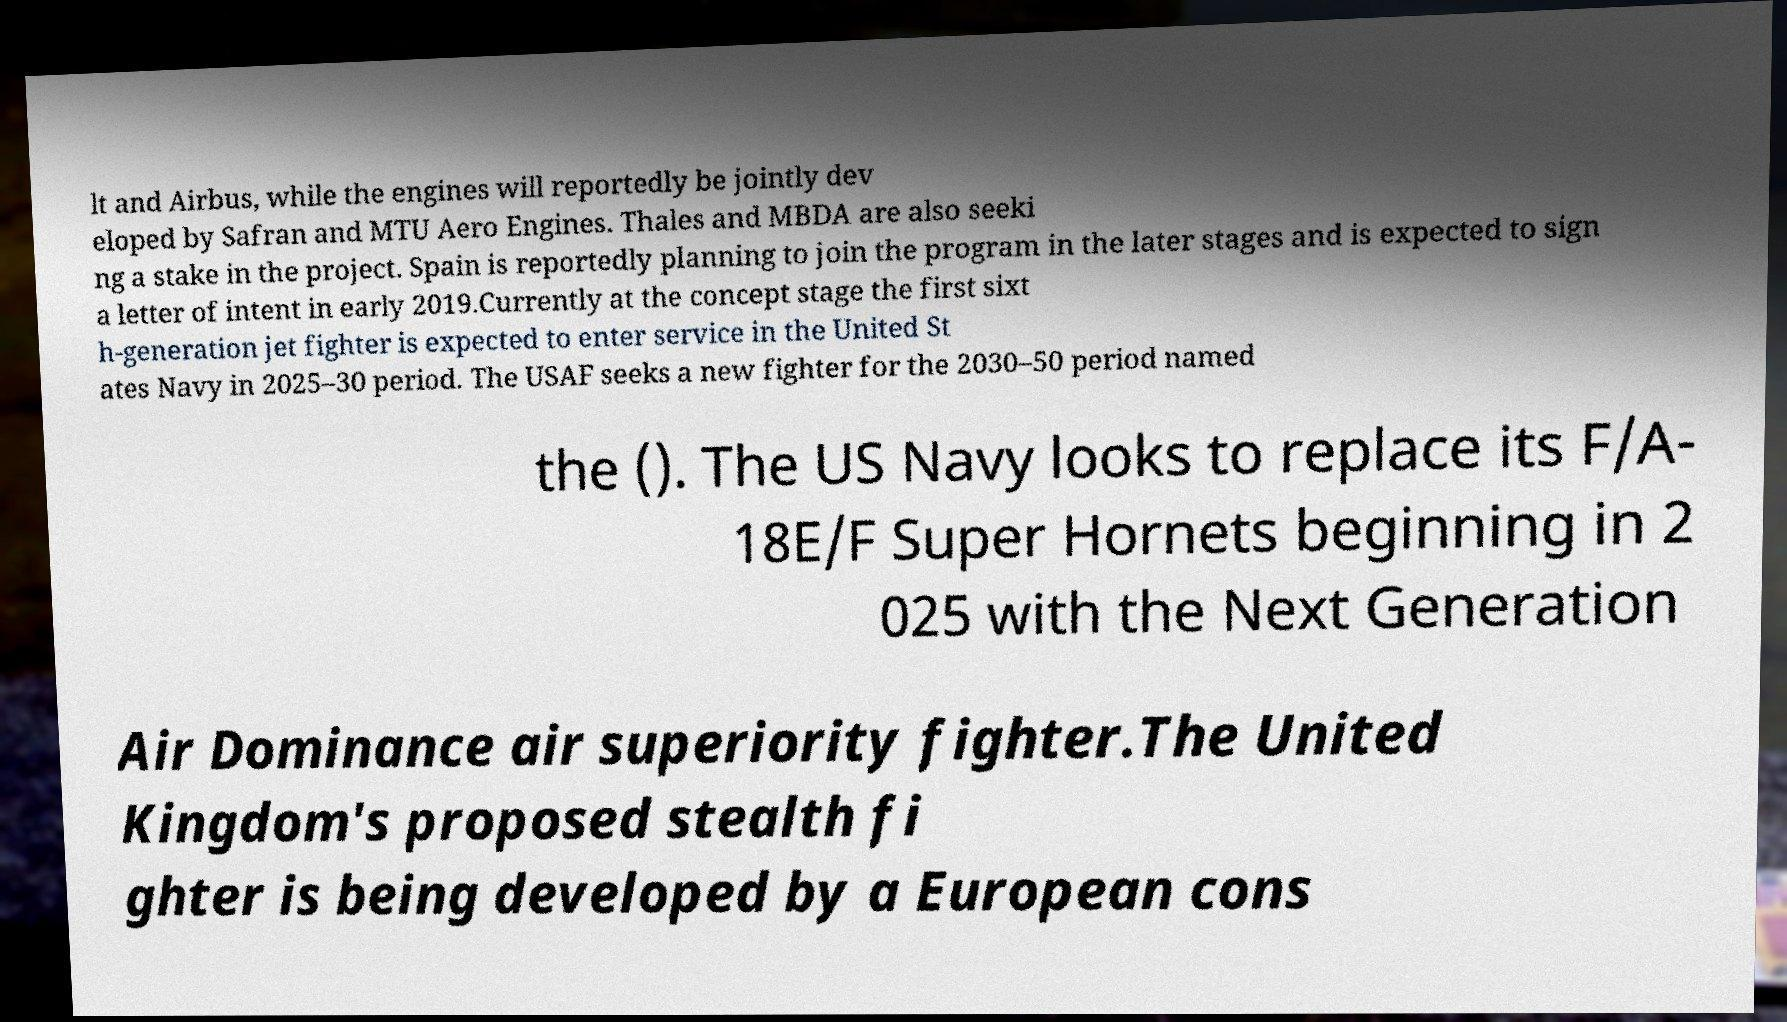I need the written content from this picture converted into text. Can you do that? lt and Airbus, while the engines will reportedly be jointly dev eloped by Safran and MTU Aero Engines. Thales and MBDA are also seeki ng a stake in the project. Spain is reportedly planning to join the program in the later stages and is expected to sign a letter of intent in early 2019.Currently at the concept stage the first sixt h-generation jet fighter is expected to enter service in the United St ates Navy in 2025–30 period. The USAF seeks a new fighter for the 2030–50 period named the (). The US Navy looks to replace its F/A- 18E/F Super Hornets beginning in 2 025 with the Next Generation Air Dominance air superiority fighter.The United Kingdom's proposed stealth fi ghter is being developed by a European cons 